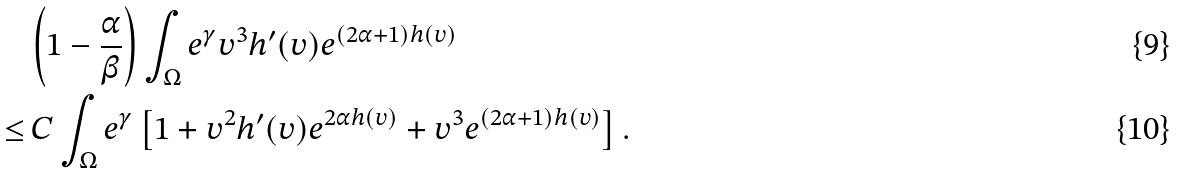Convert formula to latex. <formula><loc_0><loc_0><loc_500><loc_500>& \left ( 1 - \frac { \alpha } { \beta } \right ) \int _ { \Omega } e ^ { \gamma } v ^ { 3 } h ^ { \prime } ( v ) e ^ { ( 2 \alpha + 1 ) h ( v ) } \\ \leq & \, C \int _ { \Omega } e ^ { \gamma } \left [ 1 + v ^ { 2 } h ^ { \prime } ( v ) e ^ { 2 \alpha h ( v ) } + v ^ { 3 } e ^ { ( 2 \alpha + 1 ) h ( v ) } \right ] .</formula> 